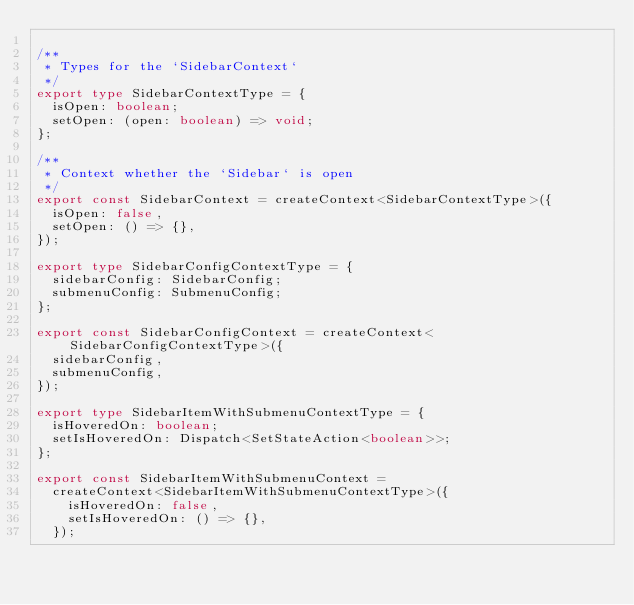<code> <loc_0><loc_0><loc_500><loc_500><_TypeScript_>
/**
 * Types for the `SidebarContext`
 */
export type SidebarContextType = {
  isOpen: boolean;
  setOpen: (open: boolean) => void;
};

/**
 * Context whether the `Sidebar` is open
 */
export const SidebarContext = createContext<SidebarContextType>({
  isOpen: false,
  setOpen: () => {},
});

export type SidebarConfigContextType = {
  sidebarConfig: SidebarConfig;
  submenuConfig: SubmenuConfig;
};

export const SidebarConfigContext = createContext<SidebarConfigContextType>({
  sidebarConfig,
  submenuConfig,
});

export type SidebarItemWithSubmenuContextType = {
  isHoveredOn: boolean;
  setIsHoveredOn: Dispatch<SetStateAction<boolean>>;
};

export const SidebarItemWithSubmenuContext =
  createContext<SidebarItemWithSubmenuContextType>({
    isHoveredOn: false,
    setIsHoveredOn: () => {},
  });
</code> 